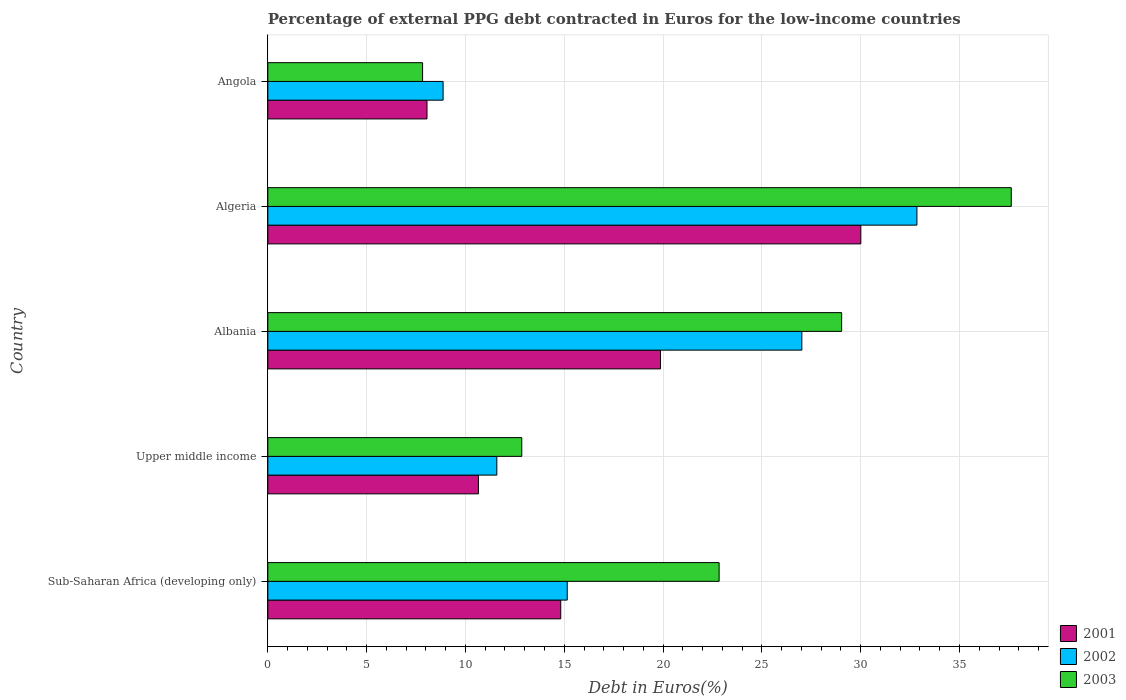How many different coloured bars are there?
Give a very brief answer. 3. Are the number of bars on each tick of the Y-axis equal?
Provide a short and direct response. Yes. What is the label of the 1st group of bars from the top?
Provide a short and direct response. Angola. In how many cases, is the number of bars for a given country not equal to the number of legend labels?
Your response must be concise. 0. What is the percentage of external PPG debt contracted in Euros in 2003 in Algeria?
Your response must be concise. 37.62. Across all countries, what is the maximum percentage of external PPG debt contracted in Euros in 2002?
Provide a short and direct response. 32.85. Across all countries, what is the minimum percentage of external PPG debt contracted in Euros in 2001?
Your response must be concise. 8.05. In which country was the percentage of external PPG debt contracted in Euros in 2001 maximum?
Your response must be concise. Algeria. In which country was the percentage of external PPG debt contracted in Euros in 2001 minimum?
Offer a very short reply. Angola. What is the total percentage of external PPG debt contracted in Euros in 2002 in the graph?
Give a very brief answer. 95.47. What is the difference between the percentage of external PPG debt contracted in Euros in 2003 in Sub-Saharan Africa (developing only) and that in Upper middle income?
Your answer should be compact. 9.99. What is the difference between the percentage of external PPG debt contracted in Euros in 2003 in Sub-Saharan Africa (developing only) and the percentage of external PPG debt contracted in Euros in 2001 in Angola?
Ensure brevity in your answer.  14.78. What is the average percentage of external PPG debt contracted in Euros in 2002 per country?
Your answer should be very brief. 19.09. What is the difference between the percentage of external PPG debt contracted in Euros in 2002 and percentage of external PPG debt contracted in Euros in 2003 in Algeria?
Ensure brevity in your answer.  -4.77. In how many countries, is the percentage of external PPG debt contracted in Euros in 2003 greater than 31 %?
Offer a very short reply. 1. What is the ratio of the percentage of external PPG debt contracted in Euros in 2003 in Sub-Saharan Africa (developing only) to that in Upper middle income?
Provide a short and direct response. 1.78. Is the difference between the percentage of external PPG debt contracted in Euros in 2002 in Albania and Upper middle income greater than the difference between the percentage of external PPG debt contracted in Euros in 2003 in Albania and Upper middle income?
Ensure brevity in your answer.  No. What is the difference between the highest and the second highest percentage of external PPG debt contracted in Euros in 2001?
Your answer should be compact. 10.14. What is the difference between the highest and the lowest percentage of external PPG debt contracted in Euros in 2002?
Your response must be concise. 23.98. Is the sum of the percentage of external PPG debt contracted in Euros in 2003 in Algeria and Sub-Saharan Africa (developing only) greater than the maximum percentage of external PPG debt contracted in Euros in 2001 across all countries?
Provide a short and direct response. Yes. What does the 2nd bar from the top in Sub-Saharan Africa (developing only) represents?
Ensure brevity in your answer.  2002. What does the 1st bar from the bottom in Albania represents?
Provide a succinct answer. 2001. How many bars are there?
Offer a very short reply. 15. Are all the bars in the graph horizontal?
Ensure brevity in your answer.  Yes. Are the values on the major ticks of X-axis written in scientific E-notation?
Give a very brief answer. No. Where does the legend appear in the graph?
Your answer should be very brief. Bottom right. How many legend labels are there?
Ensure brevity in your answer.  3. What is the title of the graph?
Provide a succinct answer. Percentage of external PPG debt contracted in Euros for the low-income countries. Does "2000" appear as one of the legend labels in the graph?
Provide a succinct answer. No. What is the label or title of the X-axis?
Offer a very short reply. Debt in Euros(%). What is the label or title of the Y-axis?
Your answer should be compact. Country. What is the Debt in Euros(%) in 2001 in Sub-Saharan Africa (developing only)?
Give a very brief answer. 14.82. What is the Debt in Euros(%) in 2002 in Sub-Saharan Africa (developing only)?
Provide a short and direct response. 15.15. What is the Debt in Euros(%) of 2003 in Sub-Saharan Africa (developing only)?
Your answer should be very brief. 22.84. What is the Debt in Euros(%) of 2001 in Upper middle income?
Offer a terse response. 10.66. What is the Debt in Euros(%) in 2002 in Upper middle income?
Provide a succinct answer. 11.59. What is the Debt in Euros(%) of 2003 in Upper middle income?
Your answer should be very brief. 12.85. What is the Debt in Euros(%) in 2001 in Albania?
Your answer should be very brief. 19.87. What is the Debt in Euros(%) in 2002 in Albania?
Provide a succinct answer. 27.02. What is the Debt in Euros(%) in 2003 in Albania?
Provide a succinct answer. 29.04. What is the Debt in Euros(%) of 2001 in Algeria?
Your answer should be compact. 30.01. What is the Debt in Euros(%) of 2002 in Algeria?
Keep it short and to the point. 32.85. What is the Debt in Euros(%) of 2003 in Algeria?
Your response must be concise. 37.62. What is the Debt in Euros(%) of 2001 in Angola?
Offer a terse response. 8.05. What is the Debt in Euros(%) of 2002 in Angola?
Your response must be concise. 8.87. What is the Debt in Euros(%) of 2003 in Angola?
Give a very brief answer. 7.83. Across all countries, what is the maximum Debt in Euros(%) of 2001?
Keep it short and to the point. 30.01. Across all countries, what is the maximum Debt in Euros(%) of 2002?
Offer a terse response. 32.85. Across all countries, what is the maximum Debt in Euros(%) of 2003?
Keep it short and to the point. 37.62. Across all countries, what is the minimum Debt in Euros(%) of 2001?
Give a very brief answer. 8.05. Across all countries, what is the minimum Debt in Euros(%) of 2002?
Your response must be concise. 8.87. Across all countries, what is the minimum Debt in Euros(%) of 2003?
Your answer should be very brief. 7.83. What is the total Debt in Euros(%) of 2001 in the graph?
Your answer should be compact. 83.41. What is the total Debt in Euros(%) of 2002 in the graph?
Your answer should be very brief. 95.47. What is the total Debt in Euros(%) in 2003 in the graph?
Provide a short and direct response. 110.17. What is the difference between the Debt in Euros(%) in 2001 in Sub-Saharan Africa (developing only) and that in Upper middle income?
Offer a very short reply. 4.17. What is the difference between the Debt in Euros(%) in 2002 in Sub-Saharan Africa (developing only) and that in Upper middle income?
Keep it short and to the point. 3.56. What is the difference between the Debt in Euros(%) of 2003 in Sub-Saharan Africa (developing only) and that in Upper middle income?
Provide a short and direct response. 9.99. What is the difference between the Debt in Euros(%) in 2001 in Sub-Saharan Africa (developing only) and that in Albania?
Your answer should be compact. -5.05. What is the difference between the Debt in Euros(%) of 2002 in Sub-Saharan Africa (developing only) and that in Albania?
Provide a succinct answer. -11.87. What is the difference between the Debt in Euros(%) of 2003 in Sub-Saharan Africa (developing only) and that in Albania?
Your answer should be compact. -6.2. What is the difference between the Debt in Euros(%) of 2001 in Sub-Saharan Africa (developing only) and that in Algeria?
Your answer should be very brief. -15.18. What is the difference between the Debt in Euros(%) in 2002 in Sub-Saharan Africa (developing only) and that in Algeria?
Offer a terse response. -17.7. What is the difference between the Debt in Euros(%) in 2003 in Sub-Saharan Africa (developing only) and that in Algeria?
Keep it short and to the point. -14.78. What is the difference between the Debt in Euros(%) in 2001 in Sub-Saharan Africa (developing only) and that in Angola?
Your answer should be very brief. 6.77. What is the difference between the Debt in Euros(%) in 2002 in Sub-Saharan Africa (developing only) and that in Angola?
Ensure brevity in your answer.  6.28. What is the difference between the Debt in Euros(%) in 2003 in Sub-Saharan Africa (developing only) and that in Angola?
Give a very brief answer. 15.01. What is the difference between the Debt in Euros(%) in 2001 in Upper middle income and that in Albania?
Offer a very short reply. -9.22. What is the difference between the Debt in Euros(%) of 2002 in Upper middle income and that in Albania?
Ensure brevity in your answer.  -15.43. What is the difference between the Debt in Euros(%) of 2003 in Upper middle income and that in Albania?
Offer a very short reply. -16.19. What is the difference between the Debt in Euros(%) in 2001 in Upper middle income and that in Algeria?
Offer a very short reply. -19.35. What is the difference between the Debt in Euros(%) of 2002 in Upper middle income and that in Algeria?
Your answer should be compact. -21.26. What is the difference between the Debt in Euros(%) in 2003 in Upper middle income and that in Algeria?
Provide a short and direct response. -24.77. What is the difference between the Debt in Euros(%) of 2001 in Upper middle income and that in Angola?
Make the answer very short. 2.6. What is the difference between the Debt in Euros(%) of 2002 in Upper middle income and that in Angola?
Ensure brevity in your answer.  2.72. What is the difference between the Debt in Euros(%) in 2003 in Upper middle income and that in Angola?
Make the answer very short. 5.02. What is the difference between the Debt in Euros(%) in 2001 in Albania and that in Algeria?
Your response must be concise. -10.14. What is the difference between the Debt in Euros(%) of 2002 in Albania and that in Algeria?
Provide a short and direct response. -5.82. What is the difference between the Debt in Euros(%) in 2003 in Albania and that in Algeria?
Ensure brevity in your answer.  -8.58. What is the difference between the Debt in Euros(%) in 2001 in Albania and that in Angola?
Keep it short and to the point. 11.82. What is the difference between the Debt in Euros(%) in 2002 in Albania and that in Angola?
Your answer should be compact. 18.15. What is the difference between the Debt in Euros(%) of 2003 in Albania and that in Angola?
Your answer should be compact. 21.21. What is the difference between the Debt in Euros(%) of 2001 in Algeria and that in Angola?
Offer a very short reply. 21.95. What is the difference between the Debt in Euros(%) in 2002 in Algeria and that in Angola?
Your answer should be compact. 23.98. What is the difference between the Debt in Euros(%) in 2003 in Algeria and that in Angola?
Keep it short and to the point. 29.79. What is the difference between the Debt in Euros(%) of 2001 in Sub-Saharan Africa (developing only) and the Debt in Euros(%) of 2002 in Upper middle income?
Offer a very short reply. 3.23. What is the difference between the Debt in Euros(%) in 2001 in Sub-Saharan Africa (developing only) and the Debt in Euros(%) in 2003 in Upper middle income?
Your response must be concise. 1.97. What is the difference between the Debt in Euros(%) in 2002 in Sub-Saharan Africa (developing only) and the Debt in Euros(%) in 2003 in Upper middle income?
Your response must be concise. 2.3. What is the difference between the Debt in Euros(%) in 2001 in Sub-Saharan Africa (developing only) and the Debt in Euros(%) in 2002 in Albania?
Offer a terse response. -12.2. What is the difference between the Debt in Euros(%) of 2001 in Sub-Saharan Africa (developing only) and the Debt in Euros(%) of 2003 in Albania?
Your answer should be very brief. -14.21. What is the difference between the Debt in Euros(%) in 2002 in Sub-Saharan Africa (developing only) and the Debt in Euros(%) in 2003 in Albania?
Offer a terse response. -13.89. What is the difference between the Debt in Euros(%) in 2001 in Sub-Saharan Africa (developing only) and the Debt in Euros(%) in 2002 in Algeria?
Give a very brief answer. -18.02. What is the difference between the Debt in Euros(%) of 2001 in Sub-Saharan Africa (developing only) and the Debt in Euros(%) of 2003 in Algeria?
Keep it short and to the point. -22.8. What is the difference between the Debt in Euros(%) of 2002 in Sub-Saharan Africa (developing only) and the Debt in Euros(%) of 2003 in Algeria?
Offer a terse response. -22.47. What is the difference between the Debt in Euros(%) in 2001 in Sub-Saharan Africa (developing only) and the Debt in Euros(%) in 2002 in Angola?
Offer a terse response. 5.95. What is the difference between the Debt in Euros(%) of 2001 in Sub-Saharan Africa (developing only) and the Debt in Euros(%) of 2003 in Angola?
Your answer should be compact. 6.99. What is the difference between the Debt in Euros(%) of 2002 in Sub-Saharan Africa (developing only) and the Debt in Euros(%) of 2003 in Angola?
Your answer should be compact. 7.32. What is the difference between the Debt in Euros(%) in 2001 in Upper middle income and the Debt in Euros(%) in 2002 in Albania?
Give a very brief answer. -16.37. What is the difference between the Debt in Euros(%) in 2001 in Upper middle income and the Debt in Euros(%) in 2003 in Albania?
Make the answer very short. -18.38. What is the difference between the Debt in Euros(%) of 2002 in Upper middle income and the Debt in Euros(%) of 2003 in Albania?
Your answer should be compact. -17.45. What is the difference between the Debt in Euros(%) of 2001 in Upper middle income and the Debt in Euros(%) of 2002 in Algeria?
Your answer should be very brief. -22.19. What is the difference between the Debt in Euros(%) of 2001 in Upper middle income and the Debt in Euros(%) of 2003 in Algeria?
Your answer should be compact. -26.96. What is the difference between the Debt in Euros(%) in 2002 in Upper middle income and the Debt in Euros(%) in 2003 in Algeria?
Keep it short and to the point. -26.03. What is the difference between the Debt in Euros(%) in 2001 in Upper middle income and the Debt in Euros(%) in 2002 in Angola?
Offer a very short reply. 1.79. What is the difference between the Debt in Euros(%) in 2001 in Upper middle income and the Debt in Euros(%) in 2003 in Angola?
Offer a very short reply. 2.83. What is the difference between the Debt in Euros(%) in 2002 in Upper middle income and the Debt in Euros(%) in 2003 in Angola?
Give a very brief answer. 3.76. What is the difference between the Debt in Euros(%) of 2001 in Albania and the Debt in Euros(%) of 2002 in Algeria?
Provide a short and direct response. -12.97. What is the difference between the Debt in Euros(%) of 2001 in Albania and the Debt in Euros(%) of 2003 in Algeria?
Your answer should be very brief. -17.75. What is the difference between the Debt in Euros(%) in 2002 in Albania and the Debt in Euros(%) in 2003 in Algeria?
Offer a very short reply. -10.6. What is the difference between the Debt in Euros(%) of 2001 in Albania and the Debt in Euros(%) of 2002 in Angola?
Give a very brief answer. 11. What is the difference between the Debt in Euros(%) of 2001 in Albania and the Debt in Euros(%) of 2003 in Angola?
Your response must be concise. 12.04. What is the difference between the Debt in Euros(%) of 2002 in Albania and the Debt in Euros(%) of 2003 in Angola?
Provide a short and direct response. 19.19. What is the difference between the Debt in Euros(%) of 2001 in Algeria and the Debt in Euros(%) of 2002 in Angola?
Provide a succinct answer. 21.14. What is the difference between the Debt in Euros(%) in 2001 in Algeria and the Debt in Euros(%) in 2003 in Angola?
Your answer should be compact. 22.18. What is the difference between the Debt in Euros(%) of 2002 in Algeria and the Debt in Euros(%) of 2003 in Angola?
Give a very brief answer. 25.02. What is the average Debt in Euros(%) of 2001 per country?
Offer a terse response. 16.68. What is the average Debt in Euros(%) in 2002 per country?
Provide a short and direct response. 19.09. What is the average Debt in Euros(%) in 2003 per country?
Your answer should be compact. 22.03. What is the difference between the Debt in Euros(%) of 2001 and Debt in Euros(%) of 2002 in Sub-Saharan Africa (developing only)?
Offer a very short reply. -0.33. What is the difference between the Debt in Euros(%) of 2001 and Debt in Euros(%) of 2003 in Sub-Saharan Africa (developing only)?
Offer a terse response. -8.01. What is the difference between the Debt in Euros(%) in 2002 and Debt in Euros(%) in 2003 in Sub-Saharan Africa (developing only)?
Offer a very short reply. -7.69. What is the difference between the Debt in Euros(%) of 2001 and Debt in Euros(%) of 2002 in Upper middle income?
Provide a succinct answer. -0.93. What is the difference between the Debt in Euros(%) of 2001 and Debt in Euros(%) of 2003 in Upper middle income?
Keep it short and to the point. -2.19. What is the difference between the Debt in Euros(%) of 2002 and Debt in Euros(%) of 2003 in Upper middle income?
Give a very brief answer. -1.26. What is the difference between the Debt in Euros(%) in 2001 and Debt in Euros(%) in 2002 in Albania?
Provide a short and direct response. -7.15. What is the difference between the Debt in Euros(%) of 2001 and Debt in Euros(%) of 2003 in Albania?
Provide a short and direct response. -9.16. What is the difference between the Debt in Euros(%) in 2002 and Debt in Euros(%) in 2003 in Albania?
Offer a terse response. -2.01. What is the difference between the Debt in Euros(%) of 2001 and Debt in Euros(%) of 2002 in Algeria?
Provide a succinct answer. -2.84. What is the difference between the Debt in Euros(%) in 2001 and Debt in Euros(%) in 2003 in Algeria?
Your answer should be compact. -7.61. What is the difference between the Debt in Euros(%) of 2002 and Debt in Euros(%) of 2003 in Algeria?
Your response must be concise. -4.77. What is the difference between the Debt in Euros(%) in 2001 and Debt in Euros(%) in 2002 in Angola?
Offer a very short reply. -0.81. What is the difference between the Debt in Euros(%) of 2001 and Debt in Euros(%) of 2003 in Angola?
Provide a succinct answer. 0.22. What is the difference between the Debt in Euros(%) in 2002 and Debt in Euros(%) in 2003 in Angola?
Keep it short and to the point. 1.04. What is the ratio of the Debt in Euros(%) of 2001 in Sub-Saharan Africa (developing only) to that in Upper middle income?
Make the answer very short. 1.39. What is the ratio of the Debt in Euros(%) of 2002 in Sub-Saharan Africa (developing only) to that in Upper middle income?
Offer a terse response. 1.31. What is the ratio of the Debt in Euros(%) of 2003 in Sub-Saharan Africa (developing only) to that in Upper middle income?
Provide a succinct answer. 1.78. What is the ratio of the Debt in Euros(%) in 2001 in Sub-Saharan Africa (developing only) to that in Albania?
Offer a very short reply. 0.75. What is the ratio of the Debt in Euros(%) of 2002 in Sub-Saharan Africa (developing only) to that in Albania?
Keep it short and to the point. 0.56. What is the ratio of the Debt in Euros(%) of 2003 in Sub-Saharan Africa (developing only) to that in Albania?
Your response must be concise. 0.79. What is the ratio of the Debt in Euros(%) in 2001 in Sub-Saharan Africa (developing only) to that in Algeria?
Give a very brief answer. 0.49. What is the ratio of the Debt in Euros(%) of 2002 in Sub-Saharan Africa (developing only) to that in Algeria?
Your response must be concise. 0.46. What is the ratio of the Debt in Euros(%) in 2003 in Sub-Saharan Africa (developing only) to that in Algeria?
Keep it short and to the point. 0.61. What is the ratio of the Debt in Euros(%) of 2001 in Sub-Saharan Africa (developing only) to that in Angola?
Offer a terse response. 1.84. What is the ratio of the Debt in Euros(%) in 2002 in Sub-Saharan Africa (developing only) to that in Angola?
Keep it short and to the point. 1.71. What is the ratio of the Debt in Euros(%) in 2003 in Sub-Saharan Africa (developing only) to that in Angola?
Your response must be concise. 2.92. What is the ratio of the Debt in Euros(%) of 2001 in Upper middle income to that in Albania?
Give a very brief answer. 0.54. What is the ratio of the Debt in Euros(%) of 2002 in Upper middle income to that in Albania?
Offer a terse response. 0.43. What is the ratio of the Debt in Euros(%) in 2003 in Upper middle income to that in Albania?
Your answer should be compact. 0.44. What is the ratio of the Debt in Euros(%) of 2001 in Upper middle income to that in Algeria?
Make the answer very short. 0.36. What is the ratio of the Debt in Euros(%) of 2002 in Upper middle income to that in Algeria?
Ensure brevity in your answer.  0.35. What is the ratio of the Debt in Euros(%) in 2003 in Upper middle income to that in Algeria?
Your response must be concise. 0.34. What is the ratio of the Debt in Euros(%) in 2001 in Upper middle income to that in Angola?
Provide a succinct answer. 1.32. What is the ratio of the Debt in Euros(%) of 2002 in Upper middle income to that in Angola?
Your answer should be very brief. 1.31. What is the ratio of the Debt in Euros(%) of 2003 in Upper middle income to that in Angola?
Your response must be concise. 1.64. What is the ratio of the Debt in Euros(%) in 2001 in Albania to that in Algeria?
Your answer should be compact. 0.66. What is the ratio of the Debt in Euros(%) in 2002 in Albania to that in Algeria?
Provide a short and direct response. 0.82. What is the ratio of the Debt in Euros(%) of 2003 in Albania to that in Algeria?
Give a very brief answer. 0.77. What is the ratio of the Debt in Euros(%) in 2001 in Albania to that in Angola?
Make the answer very short. 2.47. What is the ratio of the Debt in Euros(%) of 2002 in Albania to that in Angola?
Provide a short and direct response. 3.05. What is the ratio of the Debt in Euros(%) in 2003 in Albania to that in Angola?
Make the answer very short. 3.71. What is the ratio of the Debt in Euros(%) in 2001 in Algeria to that in Angola?
Ensure brevity in your answer.  3.73. What is the ratio of the Debt in Euros(%) in 2002 in Algeria to that in Angola?
Give a very brief answer. 3.7. What is the ratio of the Debt in Euros(%) of 2003 in Algeria to that in Angola?
Give a very brief answer. 4.8. What is the difference between the highest and the second highest Debt in Euros(%) of 2001?
Keep it short and to the point. 10.14. What is the difference between the highest and the second highest Debt in Euros(%) of 2002?
Make the answer very short. 5.82. What is the difference between the highest and the second highest Debt in Euros(%) in 2003?
Your answer should be very brief. 8.58. What is the difference between the highest and the lowest Debt in Euros(%) in 2001?
Your answer should be compact. 21.95. What is the difference between the highest and the lowest Debt in Euros(%) of 2002?
Your answer should be very brief. 23.98. What is the difference between the highest and the lowest Debt in Euros(%) of 2003?
Your answer should be compact. 29.79. 